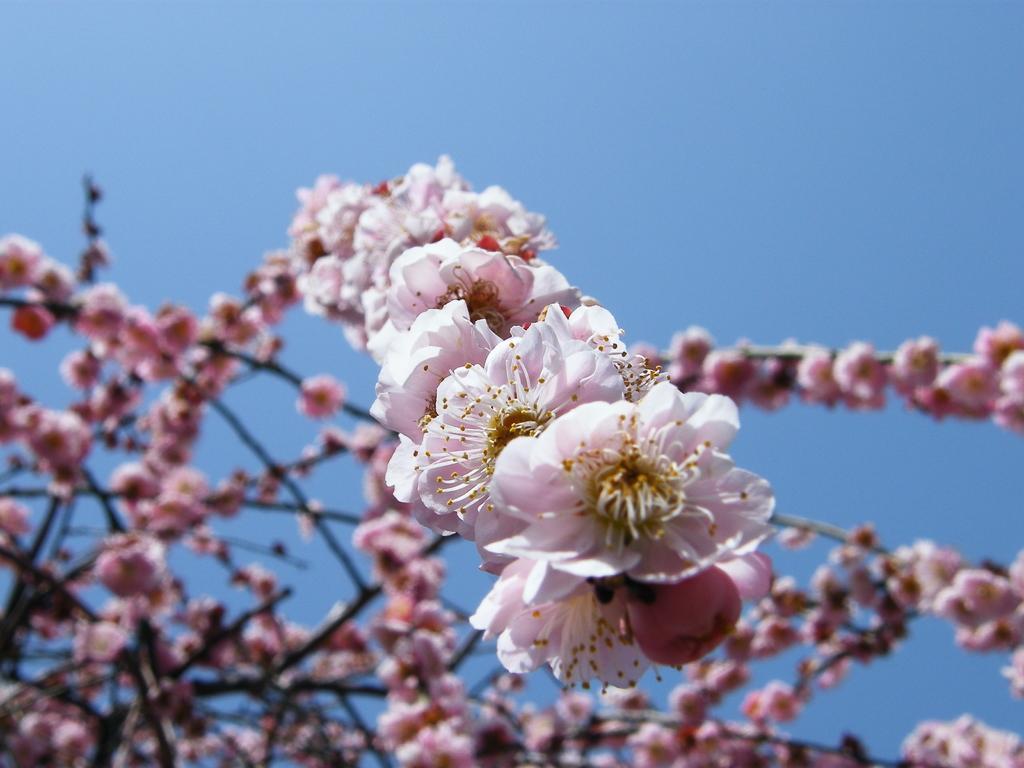Describe this image in one or two sentences. As we can see in the image there is a tree, pink color flower and a sky. 